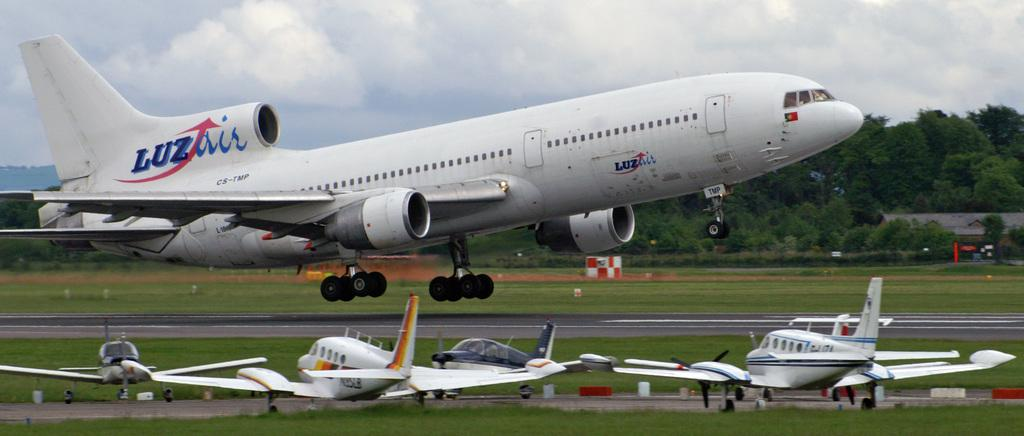What is the main subject of the image? The main subject of the image is an airplane. What can be seen on the ground in the image? There is grass on the ground in the image. What is visible in the background of the image? There are trees in the background of the image. How would you describe the sky in the image? The sky is cloudy in the image. What type of scarf is the airplane wearing in the image? Airplanes do not wear scarves, as they are inanimate objects. 